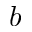<formula> <loc_0><loc_0><loc_500><loc_500>b</formula> 